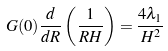Convert formula to latex. <formula><loc_0><loc_0><loc_500><loc_500>G ( 0 ) \frac { d } { d R } \left ( \frac { 1 } { R H } \right ) = \frac { 4 \lambda _ { 1 } } { H ^ { 2 } }</formula> 